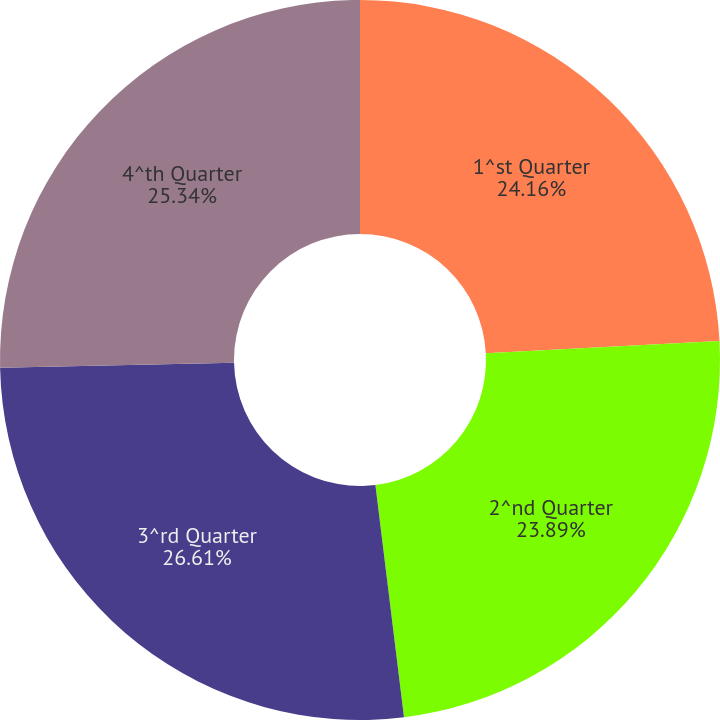<chart> <loc_0><loc_0><loc_500><loc_500><pie_chart><fcel>1^st Quarter<fcel>2^nd Quarter<fcel>3^rd Quarter<fcel>4^th Quarter<nl><fcel>24.16%<fcel>23.89%<fcel>26.61%<fcel>25.34%<nl></chart> 